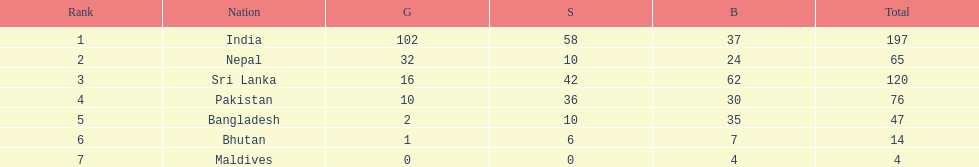Name the first country on the table? India. 